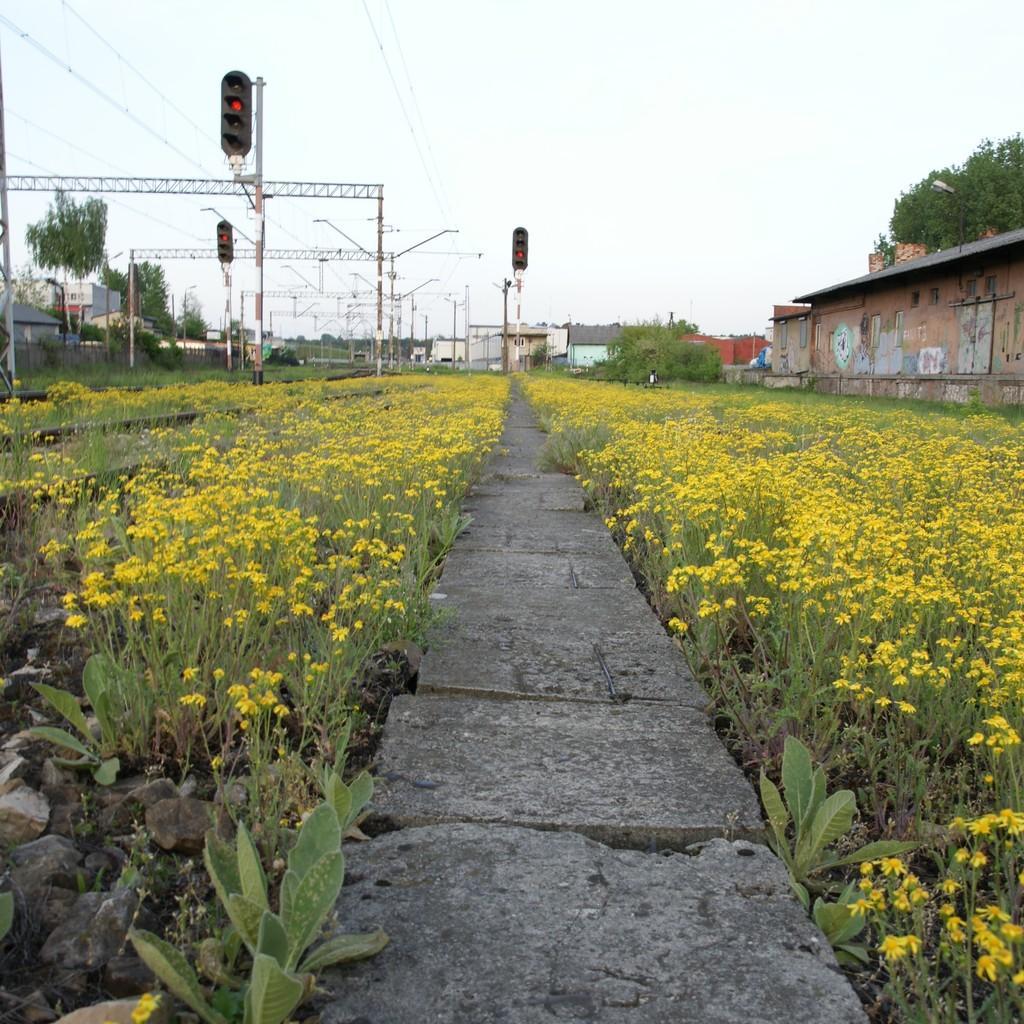How would you summarize this image in a sentence or two? In the center of the image there are cement blocks. On both right and left side of the image there are plants, buildings, trees, traffic signals, poles, rods. In the background of the image there is sky. 